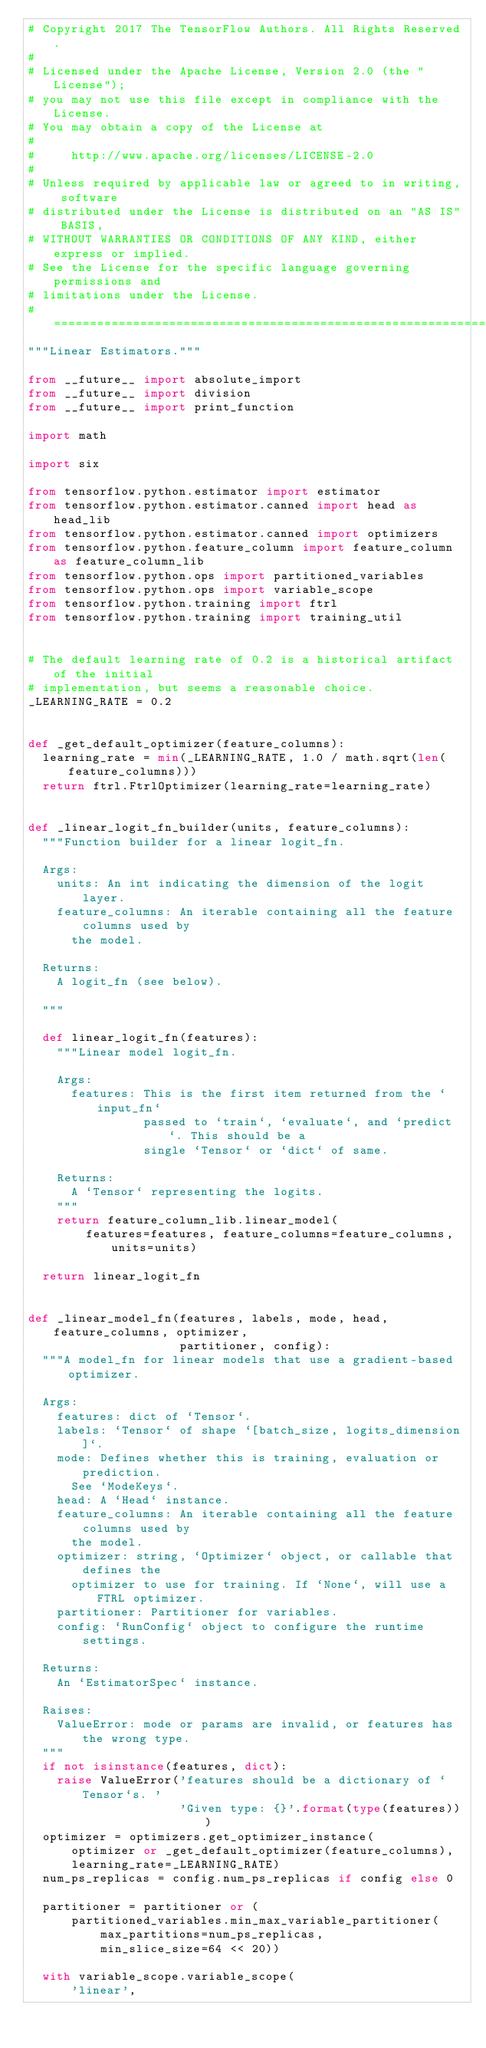<code> <loc_0><loc_0><loc_500><loc_500><_Python_># Copyright 2017 The TensorFlow Authors. All Rights Reserved.
#
# Licensed under the Apache License, Version 2.0 (the "License");
# you may not use this file except in compliance with the License.
# You may obtain a copy of the License at
#
#     http://www.apache.org/licenses/LICENSE-2.0
#
# Unless required by applicable law or agreed to in writing, software
# distributed under the License is distributed on an "AS IS" BASIS,
# WITHOUT WARRANTIES OR CONDITIONS OF ANY KIND, either express or implied.
# See the License for the specific language governing permissions and
# limitations under the License.
# ==============================================================================
"""Linear Estimators."""

from __future__ import absolute_import
from __future__ import division
from __future__ import print_function

import math

import six

from tensorflow.python.estimator import estimator
from tensorflow.python.estimator.canned import head as head_lib
from tensorflow.python.estimator.canned import optimizers
from tensorflow.python.feature_column import feature_column as feature_column_lib
from tensorflow.python.ops import partitioned_variables
from tensorflow.python.ops import variable_scope
from tensorflow.python.training import ftrl
from tensorflow.python.training import training_util


# The default learning rate of 0.2 is a historical artifact of the initial
# implementation, but seems a reasonable choice.
_LEARNING_RATE = 0.2


def _get_default_optimizer(feature_columns):
  learning_rate = min(_LEARNING_RATE, 1.0 / math.sqrt(len(feature_columns)))
  return ftrl.FtrlOptimizer(learning_rate=learning_rate)


def _linear_logit_fn_builder(units, feature_columns):
  """Function builder for a linear logit_fn.

  Args:
    units: An int indicating the dimension of the logit layer.
    feature_columns: An iterable containing all the feature columns used by
      the model.

  Returns:
    A logit_fn (see below).

  """

  def linear_logit_fn(features):
    """Linear model logit_fn.

    Args:
      features: This is the first item returned from the `input_fn`
                passed to `train`, `evaluate`, and `predict`. This should be a
                single `Tensor` or `dict` of same.

    Returns:
      A `Tensor` representing the logits.
    """
    return feature_column_lib.linear_model(
        features=features, feature_columns=feature_columns, units=units)

  return linear_logit_fn


def _linear_model_fn(features, labels, mode, head, feature_columns, optimizer,
                     partitioner, config):
  """A model_fn for linear models that use a gradient-based optimizer.

  Args:
    features: dict of `Tensor`.
    labels: `Tensor` of shape `[batch_size, logits_dimension]`.
    mode: Defines whether this is training, evaluation or prediction.
      See `ModeKeys`.
    head: A `Head` instance.
    feature_columns: An iterable containing all the feature columns used by
      the model.
    optimizer: string, `Optimizer` object, or callable that defines the
      optimizer to use for training. If `None`, will use a FTRL optimizer.
    partitioner: Partitioner for variables.
    config: `RunConfig` object to configure the runtime settings.

  Returns:
    An `EstimatorSpec` instance.

  Raises:
    ValueError: mode or params are invalid, or features has the wrong type.
  """
  if not isinstance(features, dict):
    raise ValueError('features should be a dictionary of `Tensor`s. '
                     'Given type: {}'.format(type(features)))
  optimizer = optimizers.get_optimizer_instance(
      optimizer or _get_default_optimizer(feature_columns),
      learning_rate=_LEARNING_RATE)
  num_ps_replicas = config.num_ps_replicas if config else 0

  partitioner = partitioner or (
      partitioned_variables.min_max_variable_partitioner(
          max_partitions=num_ps_replicas,
          min_slice_size=64 << 20))

  with variable_scope.variable_scope(
      'linear',</code> 